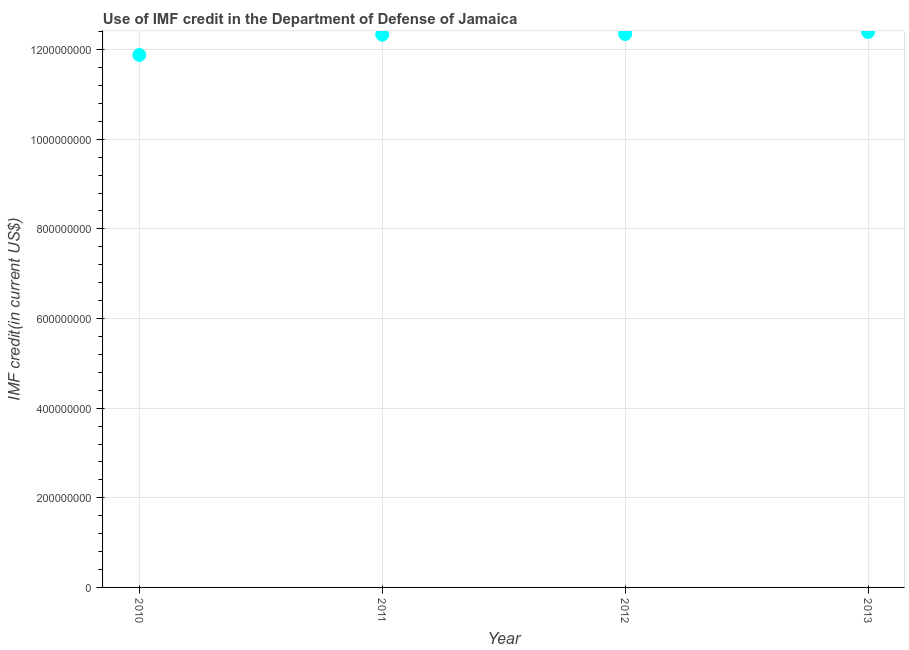What is the use of imf credit in dod in 2013?
Offer a terse response. 1.24e+09. Across all years, what is the maximum use of imf credit in dod?
Make the answer very short. 1.24e+09. Across all years, what is the minimum use of imf credit in dod?
Make the answer very short. 1.19e+09. In which year was the use of imf credit in dod maximum?
Your answer should be compact. 2013. What is the sum of the use of imf credit in dod?
Your answer should be very brief. 4.90e+09. What is the difference between the use of imf credit in dod in 2010 and 2011?
Your answer should be very brief. -4.53e+07. What is the average use of imf credit in dod per year?
Make the answer very short. 1.22e+09. What is the median use of imf credit in dod?
Provide a short and direct response. 1.23e+09. What is the ratio of the use of imf credit in dod in 2010 to that in 2011?
Provide a succinct answer. 0.96. Is the use of imf credit in dod in 2010 less than that in 2011?
Your answer should be very brief. Yes. Is the difference between the use of imf credit in dod in 2011 and 2013 greater than the difference between any two years?
Provide a succinct answer. No. What is the difference between the highest and the second highest use of imf credit in dod?
Ensure brevity in your answer.  4.65e+06. What is the difference between the highest and the lowest use of imf credit in dod?
Give a very brief answer. 5.13e+07. In how many years, is the use of imf credit in dod greater than the average use of imf credit in dod taken over all years?
Keep it short and to the point. 3. What is the difference between two consecutive major ticks on the Y-axis?
Your answer should be compact. 2.00e+08. What is the title of the graph?
Make the answer very short. Use of IMF credit in the Department of Defense of Jamaica. What is the label or title of the Y-axis?
Keep it short and to the point. IMF credit(in current US$). What is the IMF credit(in current US$) in 2010?
Give a very brief answer. 1.19e+09. What is the IMF credit(in current US$) in 2011?
Provide a short and direct response. 1.23e+09. What is the IMF credit(in current US$) in 2012?
Offer a terse response. 1.23e+09. What is the IMF credit(in current US$) in 2013?
Your answer should be compact. 1.24e+09. What is the difference between the IMF credit(in current US$) in 2010 and 2011?
Your answer should be compact. -4.53e+07. What is the difference between the IMF credit(in current US$) in 2010 and 2012?
Make the answer very short. -4.66e+07. What is the difference between the IMF credit(in current US$) in 2010 and 2013?
Your response must be concise. -5.13e+07. What is the difference between the IMF credit(in current US$) in 2011 and 2012?
Your response must be concise. -1.32e+06. What is the difference between the IMF credit(in current US$) in 2011 and 2013?
Offer a terse response. -5.98e+06. What is the difference between the IMF credit(in current US$) in 2012 and 2013?
Make the answer very short. -4.65e+06. What is the ratio of the IMF credit(in current US$) in 2010 to that in 2011?
Offer a terse response. 0.96. What is the ratio of the IMF credit(in current US$) in 2010 to that in 2013?
Provide a succinct answer. 0.96. What is the ratio of the IMF credit(in current US$) in 2012 to that in 2013?
Your answer should be compact. 1. 